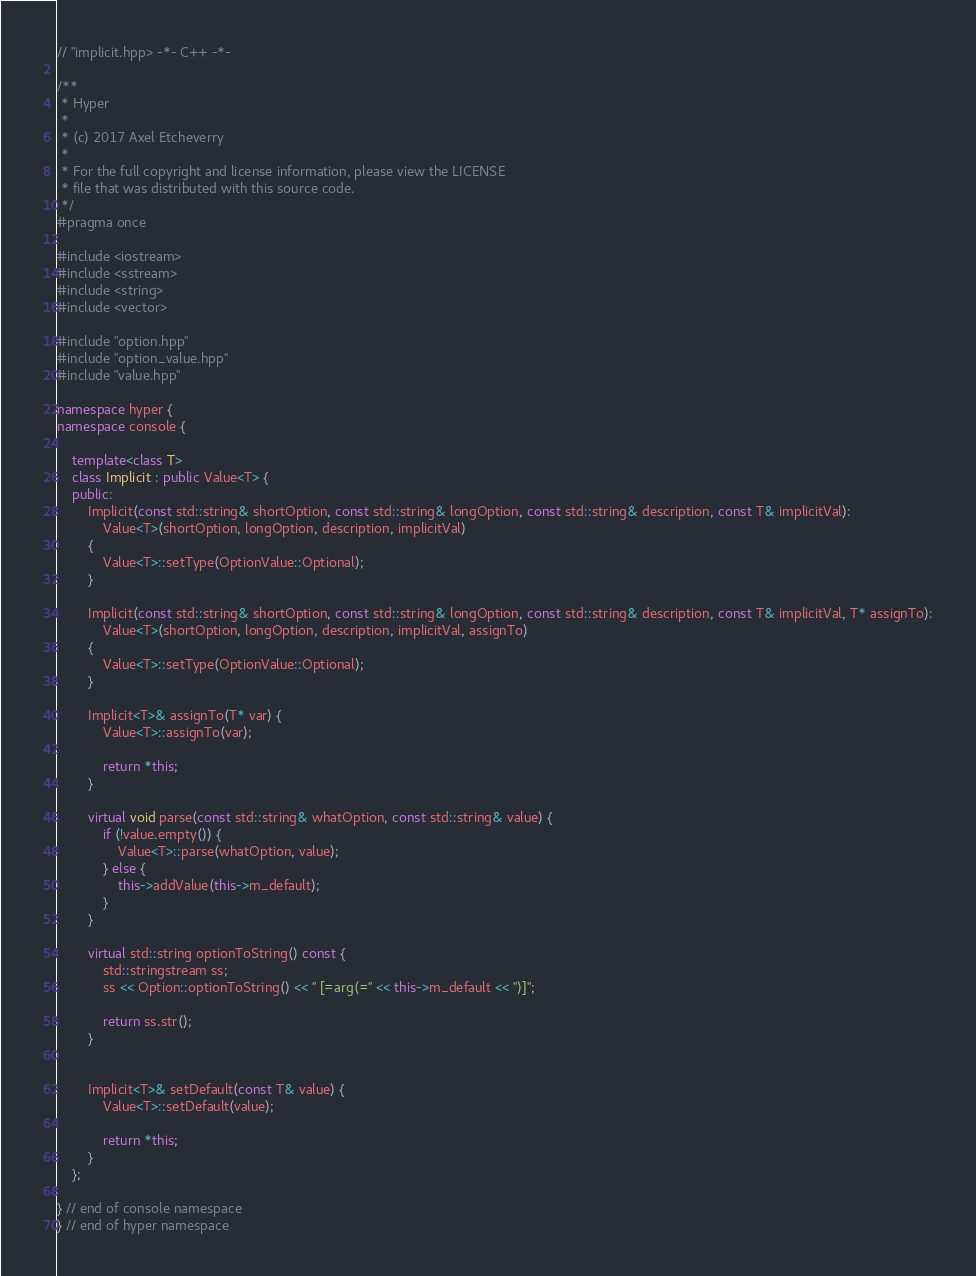<code> <loc_0><loc_0><loc_500><loc_500><_C++_>// "implicit.hpp> -*- C++ -*-

/**
 * Hyper
 *
 * (c) 2017 Axel Etcheverry
 *
 * For the full copyright and license information, please view the LICENSE
 * file that was distributed with this source code.
 */
#pragma once

#include <iostream>
#include <sstream>
#include <string>
#include <vector>

#include "option.hpp"
#include "option_value.hpp"
#include "value.hpp"

namespace hyper {
namespace console {

    template<class T>
    class Implicit : public Value<T> {
    public:
        Implicit(const std::string& shortOption, const std::string& longOption, const std::string& description, const T& implicitVal):
            Value<T>(shortOption, longOption, description, implicitVal)
        {
            Value<T>::setType(OptionValue::Optional);
        }

        Implicit(const std::string& shortOption, const std::string& longOption, const std::string& description, const T& implicitVal, T* assignTo):
            Value<T>(shortOption, longOption, description, implicitVal, assignTo)
        {
            Value<T>::setType(OptionValue::Optional);
        }

        Implicit<T>& assignTo(T* var) {
            Value<T>::assignTo(var);

            return *this;
        }

        virtual void parse(const std::string& whatOption, const std::string& value) {
            if (!value.empty()) {
                Value<T>::parse(whatOption, value);
            } else {
                this->addValue(this->m_default);
            }
        }

        virtual std::string optionToString() const {
            std::stringstream ss;
            ss << Option::optionToString() << " [=arg(=" << this->m_default << ")]";

            return ss.str();
        }


        Implicit<T>& setDefault(const T& value) {
            Value<T>::setDefault(value);

            return *this;
        }
    };

} // end of console namespace
} // end of hyper namespace
</code> 